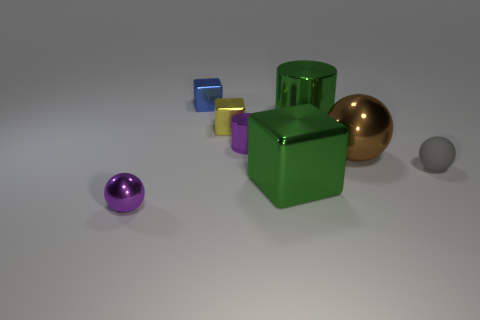What number of other yellow objects have the same shape as the rubber thing?
Make the answer very short. 0. What is the shape of the green shiny thing behind the small purple metallic thing that is on the right side of the sphere that is in front of the matte thing?
Provide a short and direct response. Cylinder. What is the material of the object that is both on the right side of the blue object and in front of the tiny gray ball?
Your answer should be compact. Metal. There is a metal cylinder that is to the right of the purple cylinder; is its size the same as the tiny yellow shiny cube?
Provide a short and direct response. No. Is there anything else that is the same size as the yellow shiny object?
Offer a very short reply. Yes. Are there more green metal cylinders on the right side of the small blue metallic block than green objects left of the large metallic ball?
Make the answer very short. No. What color is the big shiny object that is right of the green object behind the block in front of the big brown metallic object?
Give a very brief answer. Brown. There is a cylinder that is on the right side of the tiny purple cylinder; is its color the same as the small metallic cylinder?
Keep it short and to the point. No. What number of other objects are the same color as the large metallic cube?
Your answer should be compact. 1. How many objects are either tiny metallic spheres or purple metallic blocks?
Offer a very short reply. 1. 